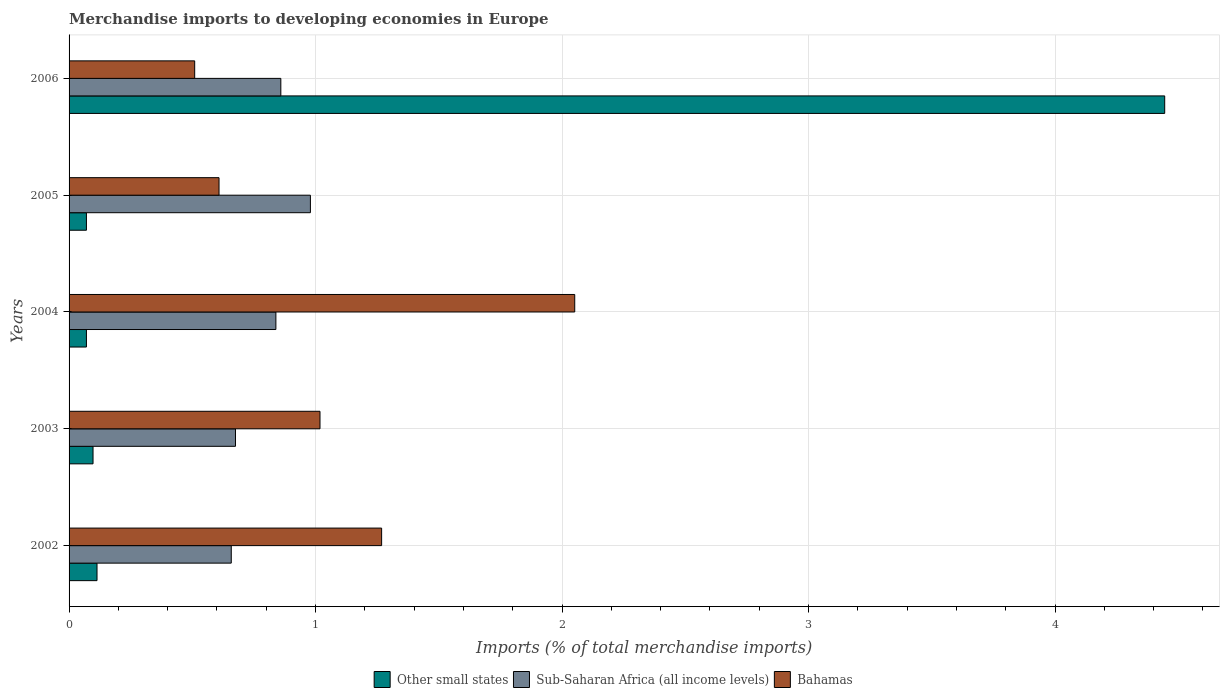How many different coloured bars are there?
Your answer should be compact. 3. Are the number of bars per tick equal to the number of legend labels?
Give a very brief answer. Yes. How many bars are there on the 4th tick from the top?
Provide a succinct answer. 3. How many bars are there on the 4th tick from the bottom?
Your response must be concise. 3. In how many cases, is the number of bars for a given year not equal to the number of legend labels?
Your response must be concise. 0. What is the percentage total merchandise imports in Sub-Saharan Africa (all income levels) in 2002?
Your answer should be very brief. 0.66. Across all years, what is the maximum percentage total merchandise imports in Other small states?
Give a very brief answer. 4.45. Across all years, what is the minimum percentage total merchandise imports in Other small states?
Offer a terse response. 0.07. In which year was the percentage total merchandise imports in Bahamas maximum?
Make the answer very short. 2004. What is the total percentage total merchandise imports in Sub-Saharan Africa (all income levels) in the graph?
Your answer should be very brief. 4.01. What is the difference between the percentage total merchandise imports in Other small states in 2005 and that in 2006?
Your answer should be compact. -4.37. What is the difference between the percentage total merchandise imports in Bahamas in 2004 and the percentage total merchandise imports in Sub-Saharan Africa (all income levels) in 2002?
Provide a short and direct response. 1.39. What is the average percentage total merchandise imports in Bahamas per year?
Offer a terse response. 1.09. In the year 2003, what is the difference between the percentage total merchandise imports in Other small states and percentage total merchandise imports in Sub-Saharan Africa (all income levels)?
Keep it short and to the point. -0.58. In how many years, is the percentage total merchandise imports in Sub-Saharan Africa (all income levels) greater than 4 %?
Provide a short and direct response. 0. What is the ratio of the percentage total merchandise imports in Bahamas in 2002 to that in 2003?
Provide a short and direct response. 1.25. Is the difference between the percentage total merchandise imports in Other small states in 2005 and 2006 greater than the difference between the percentage total merchandise imports in Sub-Saharan Africa (all income levels) in 2005 and 2006?
Offer a terse response. No. What is the difference between the highest and the second highest percentage total merchandise imports in Sub-Saharan Africa (all income levels)?
Provide a succinct answer. 0.12. What is the difference between the highest and the lowest percentage total merchandise imports in Bahamas?
Offer a terse response. 1.54. What does the 3rd bar from the top in 2006 represents?
Keep it short and to the point. Other small states. What does the 3rd bar from the bottom in 2004 represents?
Your response must be concise. Bahamas. How many bars are there?
Offer a terse response. 15. How many years are there in the graph?
Give a very brief answer. 5. What is the difference between two consecutive major ticks on the X-axis?
Ensure brevity in your answer.  1. Are the values on the major ticks of X-axis written in scientific E-notation?
Your answer should be compact. No. Does the graph contain grids?
Offer a very short reply. Yes. Where does the legend appear in the graph?
Ensure brevity in your answer.  Bottom center. How many legend labels are there?
Provide a short and direct response. 3. How are the legend labels stacked?
Provide a short and direct response. Horizontal. What is the title of the graph?
Offer a terse response. Merchandise imports to developing economies in Europe. Does "Tunisia" appear as one of the legend labels in the graph?
Give a very brief answer. No. What is the label or title of the X-axis?
Keep it short and to the point. Imports (% of total merchandise imports). What is the Imports (% of total merchandise imports) in Other small states in 2002?
Offer a terse response. 0.11. What is the Imports (% of total merchandise imports) in Sub-Saharan Africa (all income levels) in 2002?
Your answer should be compact. 0.66. What is the Imports (% of total merchandise imports) of Bahamas in 2002?
Offer a terse response. 1.27. What is the Imports (% of total merchandise imports) of Other small states in 2003?
Ensure brevity in your answer.  0.1. What is the Imports (% of total merchandise imports) of Sub-Saharan Africa (all income levels) in 2003?
Offer a very short reply. 0.68. What is the Imports (% of total merchandise imports) of Bahamas in 2003?
Ensure brevity in your answer.  1.02. What is the Imports (% of total merchandise imports) of Other small states in 2004?
Ensure brevity in your answer.  0.07. What is the Imports (% of total merchandise imports) in Sub-Saharan Africa (all income levels) in 2004?
Offer a very short reply. 0.84. What is the Imports (% of total merchandise imports) in Bahamas in 2004?
Provide a succinct answer. 2.05. What is the Imports (% of total merchandise imports) in Other small states in 2005?
Ensure brevity in your answer.  0.07. What is the Imports (% of total merchandise imports) in Sub-Saharan Africa (all income levels) in 2005?
Ensure brevity in your answer.  0.98. What is the Imports (% of total merchandise imports) of Bahamas in 2005?
Offer a terse response. 0.61. What is the Imports (% of total merchandise imports) of Other small states in 2006?
Make the answer very short. 4.45. What is the Imports (% of total merchandise imports) in Sub-Saharan Africa (all income levels) in 2006?
Offer a very short reply. 0.86. What is the Imports (% of total merchandise imports) of Bahamas in 2006?
Provide a succinct answer. 0.51. Across all years, what is the maximum Imports (% of total merchandise imports) of Other small states?
Your answer should be very brief. 4.45. Across all years, what is the maximum Imports (% of total merchandise imports) of Sub-Saharan Africa (all income levels)?
Give a very brief answer. 0.98. Across all years, what is the maximum Imports (% of total merchandise imports) in Bahamas?
Provide a short and direct response. 2.05. Across all years, what is the minimum Imports (% of total merchandise imports) in Other small states?
Provide a short and direct response. 0.07. Across all years, what is the minimum Imports (% of total merchandise imports) in Sub-Saharan Africa (all income levels)?
Give a very brief answer. 0.66. Across all years, what is the minimum Imports (% of total merchandise imports) in Bahamas?
Offer a terse response. 0.51. What is the total Imports (% of total merchandise imports) of Other small states in the graph?
Provide a succinct answer. 4.8. What is the total Imports (% of total merchandise imports) in Sub-Saharan Africa (all income levels) in the graph?
Provide a succinct answer. 4.01. What is the total Imports (% of total merchandise imports) in Bahamas in the graph?
Provide a succinct answer. 5.46. What is the difference between the Imports (% of total merchandise imports) in Other small states in 2002 and that in 2003?
Offer a terse response. 0.02. What is the difference between the Imports (% of total merchandise imports) in Sub-Saharan Africa (all income levels) in 2002 and that in 2003?
Provide a short and direct response. -0.02. What is the difference between the Imports (% of total merchandise imports) of Bahamas in 2002 and that in 2003?
Provide a succinct answer. 0.25. What is the difference between the Imports (% of total merchandise imports) in Other small states in 2002 and that in 2004?
Your answer should be very brief. 0.04. What is the difference between the Imports (% of total merchandise imports) in Sub-Saharan Africa (all income levels) in 2002 and that in 2004?
Offer a very short reply. -0.18. What is the difference between the Imports (% of total merchandise imports) of Bahamas in 2002 and that in 2004?
Offer a very short reply. -0.78. What is the difference between the Imports (% of total merchandise imports) in Other small states in 2002 and that in 2005?
Provide a short and direct response. 0.04. What is the difference between the Imports (% of total merchandise imports) of Sub-Saharan Africa (all income levels) in 2002 and that in 2005?
Your answer should be very brief. -0.32. What is the difference between the Imports (% of total merchandise imports) in Bahamas in 2002 and that in 2005?
Your response must be concise. 0.66. What is the difference between the Imports (% of total merchandise imports) in Other small states in 2002 and that in 2006?
Your answer should be very brief. -4.33. What is the difference between the Imports (% of total merchandise imports) in Sub-Saharan Africa (all income levels) in 2002 and that in 2006?
Offer a terse response. -0.2. What is the difference between the Imports (% of total merchandise imports) of Bahamas in 2002 and that in 2006?
Your response must be concise. 0.76. What is the difference between the Imports (% of total merchandise imports) of Other small states in 2003 and that in 2004?
Provide a succinct answer. 0.03. What is the difference between the Imports (% of total merchandise imports) in Sub-Saharan Africa (all income levels) in 2003 and that in 2004?
Give a very brief answer. -0.16. What is the difference between the Imports (% of total merchandise imports) in Bahamas in 2003 and that in 2004?
Provide a short and direct response. -1.03. What is the difference between the Imports (% of total merchandise imports) in Other small states in 2003 and that in 2005?
Keep it short and to the point. 0.03. What is the difference between the Imports (% of total merchandise imports) of Sub-Saharan Africa (all income levels) in 2003 and that in 2005?
Ensure brevity in your answer.  -0.3. What is the difference between the Imports (% of total merchandise imports) in Bahamas in 2003 and that in 2005?
Offer a very short reply. 0.41. What is the difference between the Imports (% of total merchandise imports) of Other small states in 2003 and that in 2006?
Your response must be concise. -4.35. What is the difference between the Imports (% of total merchandise imports) of Sub-Saharan Africa (all income levels) in 2003 and that in 2006?
Provide a succinct answer. -0.18. What is the difference between the Imports (% of total merchandise imports) in Bahamas in 2003 and that in 2006?
Provide a short and direct response. 0.51. What is the difference between the Imports (% of total merchandise imports) in Other small states in 2004 and that in 2005?
Give a very brief answer. 0. What is the difference between the Imports (% of total merchandise imports) in Sub-Saharan Africa (all income levels) in 2004 and that in 2005?
Your answer should be very brief. -0.14. What is the difference between the Imports (% of total merchandise imports) in Bahamas in 2004 and that in 2005?
Ensure brevity in your answer.  1.44. What is the difference between the Imports (% of total merchandise imports) in Other small states in 2004 and that in 2006?
Your answer should be compact. -4.37. What is the difference between the Imports (% of total merchandise imports) in Sub-Saharan Africa (all income levels) in 2004 and that in 2006?
Your response must be concise. -0.02. What is the difference between the Imports (% of total merchandise imports) in Bahamas in 2004 and that in 2006?
Your answer should be compact. 1.54. What is the difference between the Imports (% of total merchandise imports) of Other small states in 2005 and that in 2006?
Offer a terse response. -4.37. What is the difference between the Imports (% of total merchandise imports) in Sub-Saharan Africa (all income levels) in 2005 and that in 2006?
Offer a terse response. 0.12. What is the difference between the Imports (% of total merchandise imports) in Bahamas in 2005 and that in 2006?
Provide a short and direct response. 0.1. What is the difference between the Imports (% of total merchandise imports) in Other small states in 2002 and the Imports (% of total merchandise imports) in Sub-Saharan Africa (all income levels) in 2003?
Ensure brevity in your answer.  -0.56. What is the difference between the Imports (% of total merchandise imports) of Other small states in 2002 and the Imports (% of total merchandise imports) of Bahamas in 2003?
Offer a very short reply. -0.9. What is the difference between the Imports (% of total merchandise imports) of Sub-Saharan Africa (all income levels) in 2002 and the Imports (% of total merchandise imports) of Bahamas in 2003?
Your answer should be very brief. -0.36. What is the difference between the Imports (% of total merchandise imports) in Other small states in 2002 and the Imports (% of total merchandise imports) in Sub-Saharan Africa (all income levels) in 2004?
Your answer should be compact. -0.73. What is the difference between the Imports (% of total merchandise imports) of Other small states in 2002 and the Imports (% of total merchandise imports) of Bahamas in 2004?
Offer a very short reply. -1.94. What is the difference between the Imports (% of total merchandise imports) of Sub-Saharan Africa (all income levels) in 2002 and the Imports (% of total merchandise imports) of Bahamas in 2004?
Offer a very short reply. -1.39. What is the difference between the Imports (% of total merchandise imports) in Other small states in 2002 and the Imports (% of total merchandise imports) in Sub-Saharan Africa (all income levels) in 2005?
Offer a terse response. -0.87. What is the difference between the Imports (% of total merchandise imports) of Other small states in 2002 and the Imports (% of total merchandise imports) of Bahamas in 2005?
Provide a short and direct response. -0.49. What is the difference between the Imports (% of total merchandise imports) of Sub-Saharan Africa (all income levels) in 2002 and the Imports (% of total merchandise imports) of Bahamas in 2005?
Your answer should be very brief. 0.05. What is the difference between the Imports (% of total merchandise imports) of Other small states in 2002 and the Imports (% of total merchandise imports) of Sub-Saharan Africa (all income levels) in 2006?
Keep it short and to the point. -0.75. What is the difference between the Imports (% of total merchandise imports) of Other small states in 2002 and the Imports (% of total merchandise imports) of Bahamas in 2006?
Make the answer very short. -0.4. What is the difference between the Imports (% of total merchandise imports) of Sub-Saharan Africa (all income levels) in 2002 and the Imports (% of total merchandise imports) of Bahamas in 2006?
Offer a terse response. 0.15. What is the difference between the Imports (% of total merchandise imports) in Other small states in 2003 and the Imports (% of total merchandise imports) in Sub-Saharan Africa (all income levels) in 2004?
Give a very brief answer. -0.74. What is the difference between the Imports (% of total merchandise imports) of Other small states in 2003 and the Imports (% of total merchandise imports) of Bahamas in 2004?
Provide a succinct answer. -1.95. What is the difference between the Imports (% of total merchandise imports) in Sub-Saharan Africa (all income levels) in 2003 and the Imports (% of total merchandise imports) in Bahamas in 2004?
Your answer should be very brief. -1.38. What is the difference between the Imports (% of total merchandise imports) in Other small states in 2003 and the Imports (% of total merchandise imports) in Sub-Saharan Africa (all income levels) in 2005?
Keep it short and to the point. -0.88. What is the difference between the Imports (% of total merchandise imports) in Other small states in 2003 and the Imports (% of total merchandise imports) in Bahamas in 2005?
Provide a succinct answer. -0.51. What is the difference between the Imports (% of total merchandise imports) in Sub-Saharan Africa (all income levels) in 2003 and the Imports (% of total merchandise imports) in Bahamas in 2005?
Your response must be concise. 0.07. What is the difference between the Imports (% of total merchandise imports) in Other small states in 2003 and the Imports (% of total merchandise imports) in Sub-Saharan Africa (all income levels) in 2006?
Offer a terse response. -0.76. What is the difference between the Imports (% of total merchandise imports) of Other small states in 2003 and the Imports (% of total merchandise imports) of Bahamas in 2006?
Offer a very short reply. -0.41. What is the difference between the Imports (% of total merchandise imports) of Sub-Saharan Africa (all income levels) in 2003 and the Imports (% of total merchandise imports) of Bahamas in 2006?
Offer a terse response. 0.17. What is the difference between the Imports (% of total merchandise imports) in Other small states in 2004 and the Imports (% of total merchandise imports) in Sub-Saharan Africa (all income levels) in 2005?
Your answer should be compact. -0.91. What is the difference between the Imports (% of total merchandise imports) in Other small states in 2004 and the Imports (% of total merchandise imports) in Bahamas in 2005?
Keep it short and to the point. -0.54. What is the difference between the Imports (% of total merchandise imports) in Sub-Saharan Africa (all income levels) in 2004 and the Imports (% of total merchandise imports) in Bahamas in 2005?
Give a very brief answer. 0.23. What is the difference between the Imports (% of total merchandise imports) in Other small states in 2004 and the Imports (% of total merchandise imports) in Sub-Saharan Africa (all income levels) in 2006?
Give a very brief answer. -0.79. What is the difference between the Imports (% of total merchandise imports) in Other small states in 2004 and the Imports (% of total merchandise imports) in Bahamas in 2006?
Offer a terse response. -0.44. What is the difference between the Imports (% of total merchandise imports) of Sub-Saharan Africa (all income levels) in 2004 and the Imports (% of total merchandise imports) of Bahamas in 2006?
Provide a short and direct response. 0.33. What is the difference between the Imports (% of total merchandise imports) of Other small states in 2005 and the Imports (% of total merchandise imports) of Sub-Saharan Africa (all income levels) in 2006?
Ensure brevity in your answer.  -0.79. What is the difference between the Imports (% of total merchandise imports) in Other small states in 2005 and the Imports (% of total merchandise imports) in Bahamas in 2006?
Offer a terse response. -0.44. What is the difference between the Imports (% of total merchandise imports) of Sub-Saharan Africa (all income levels) in 2005 and the Imports (% of total merchandise imports) of Bahamas in 2006?
Give a very brief answer. 0.47. What is the average Imports (% of total merchandise imports) of Other small states per year?
Your response must be concise. 0.96. What is the average Imports (% of total merchandise imports) of Sub-Saharan Africa (all income levels) per year?
Your answer should be compact. 0.8. What is the average Imports (% of total merchandise imports) in Bahamas per year?
Your response must be concise. 1.09. In the year 2002, what is the difference between the Imports (% of total merchandise imports) in Other small states and Imports (% of total merchandise imports) in Sub-Saharan Africa (all income levels)?
Make the answer very short. -0.54. In the year 2002, what is the difference between the Imports (% of total merchandise imports) in Other small states and Imports (% of total merchandise imports) in Bahamas?
Give a very brief answer. -1.15. In the year 2002, what is the difference between the Imports (% of total merchandise imports) of Sub-Saharan Africa (all income levels) and Imports (% of total merchandise imports) of Bahamas?
Your answer should be compact. -0.61. In the year 2003, what is the difference between the Imports (% of total merchandise imports) in Other small states and Imports (% of total merchandise imports) in Sub-Saharan Africa (all income levels)?
Make the answer very short. -0.58. In the year 2003, what is the difference between the Imports (% of total merchandise imports) of Other small states and Imports (% of total merchandise imports) of Bahamas?
Provide a succinct answer. -0.92. In the year 2003, what is the difference between the Imports (% of total merchandise imports) in Sub-Saharan Africa (all income levels) and Imports (% of total merchandise imports) in Bahamas?
Provide a succinct answer. -0.34. In the year 2004, what is the difference between the Imports (% of total merchandise imports) of Other small states and Imports (% of total merchandise imports) of Sub-Saharan Africa (all income levels)?
Provide a short and direct response. -0.77. In the year 2004, what is the difference between the Imports (% of total merchandise imports) of Other small states and Imports (% of total merchandise imports) of Bahamas?
Provide a succinct answer. -1.98. In the year 2004, what is the difference between the Imports (% of total merchandise imports) in Sub-Saharan Africa (all income levels) and Imports (% of total merchandise imports) in Bahamas?
Your response must be concise. -1.21. In the year 2005, what is the difference between the Imports (% of total merchandise imports) of Other small states and Imports (% of total merchandise imports) of Sub-Saharan Africa (all income levels)?
Provide a succinct answer. -0.91. In the year 2005, what is the difference between the Imports (% of total merchandise imports) in Other small states and Imports (% of total merchandise imports) in Bahamas?
Your answer should be compact. -0.54. In the year 2005, what is the difference between the Imports (% of total merchandise imports) in Sub-Saharan Africa (all income levels) and Imports (% of total merchandise imports) in Bahamas?
Provide a short and direct response. 0.37. In the year 2006, what is the difference between the Imports (% of total merchandise imports) of Other small states and Imports (% of total merchandise imports) of Sub-Saharan Africa (all income levels)?
Keep it short and to the point. 3.59. In the year 2006, what is the difference between the Imports (% of total merchandise imports) of Other small states and Imports (% of total merchandise imports) of Bahamas?
Ensure brevity in your answer.  3.94. In the year 2006, what is the difference between the Imports (% of total merchandise imports) in Sub-Saharan Africa (all income levels) and Imports (% of total merchandise imports) in Bahamas?
Your answer should be compact. 0.35. What is the ratio of the Imports (% of total merchandise imports) in Other small states in 2002 to that in 2003?
Ensure brevity in your answer.  1.17. What is the ratio of the Imports (% of total merchandise imports) in Sub-Saharan Africa (all income levels) in 2002 to that in 2003?
Provide a short and direct response. 0.97. What is the ratio of the Imports (% of total merchandise imports) of Bahamas in 2002 to that in 2003?
Provide a short and direct response. 1.25. What is the ratio of the Imports (% of total merchandise imports) in Other small states in 2002 to that in 2004?
Your answer should be compact. 1.61. What is the ratio of the Imports (% of total merchandise imports) of Sub-Saharan Africa (all income levels) in 2002 to that in 2004?
Your answer should be very brief. 0.78. What is the ratio of the Imports (% of total merchandise imports) in Bahamas in 2002 to that in 2004?
Keep it short and to the point. 0.62. What is the ratio of the Imports (% of total merchandise imports) in Other small states in 2002 to that in 2005?
Give a very brief answer. 1.61. What is the ratio of the Imports (% of total merchandise imports) in Sub-Saharan Africa (all income levels) in 2002 to that in 2005?
Your answer should be very brief. 0.67. What is the ratio of the Imports (% of total merchandise imports) of Bahamas in 2002 to that in 2005?
Offer a terse response. 2.08. What is the ratio of the Imports (% of total merchandise imports) in Other small states in 2002 to that in 2006?
Give a very brief answer. 0.03. What is the ratio of the Imports (% of total merchandise imports) of Sub-Saharan Africa (all income levels) in 2002 to that in 2006?
Give a very brief answer. 0.77. What is the ratio of the Imports (% of total merchandise imports) of Bahamas in 2002 to that in 2006?
Offer a very short reply. 2.49. What is the ratio of the Imports (% of total merchandise imports) of Other small states in 2003 to that in 2004?
Provide a succinct answer. 1.38. What is the ratio of the Imports (% of total merchandise imports) in Sub-Saharan Africa (all income levels) in 2003 to that in 2004?
Ensure brevity in your answer.  0.8. What is the ratio of the Imports (% of total merchandise imports) in Bahamas in 2003 to that in 2004?
Provide a succinct answer. 0.5. What is the ratio of the Imports (% of total merchandise imports) of Other small states in 2003 to that in 2005?
Your response must be concise. 1.38. What is the ratio of the Imports (% of total merchandise imports) of Sub-Saharan Africa (all income levels) in 2003 to that in 2005?
Provide a short and direct response. 0.69. What is the ratio of the Imports (% of total merchandise imports) of Bahamas in 2003 to that in 2005?
Make the answer very short. 1.67. What is the ratio of the Imports (% of total merchandise imports) in Other small states in 2003 to that in 2006?
Your response must be concise. 0.02. What is the ratio of the Imports (% of total merchandise imports) in Sub-Saharan Africa (all income levels) in 2003 to that in 2006?
Your answer should be very brief. 0.79. What is the ratio of the Imports (% of total merchandise imports) in Bahamas in 2003 to that in 2006?
Offer a terse response. 2. What is the ratio of the Imports (% of total merchandise imports) in Other small states in 2004 to that in 2005?
Give a very brief answer. 1. What is the ratio of the Imports (% of total merchandise imports) in Sub-Saharan Africa (all income levels) in 2004 to that in 2005?
Offer a very short reply. 0.86. What is the ratio of the Imports (% of total merchandise imports) of Bahamas in 2004 to that in 2005?
Your answer should be very brief. 3.37. What is the ratio of the Imports (% of total merchandise imports) of Other small states in 2004 to that in 2006?
Provide a short and direct response. 0.02. What is the ratio of the Imports (% of total merchandise imports) in Sub-Saharan Africa (all income levels) in 2004 to that in 2006?
Your response must be concise. 0.98. What is the ratio of the Imports (% of total merchandise imports) in Bahamas in 2004 to that in 2006?
Make the answer very short. 4.03. What is the ratio of the Imports (% of total merchandise imports) in Other small states in 2005 to that in 2006?
Ensure brevity in your answer.  0.02. What is the ratio of the Imports (% of total merchandise imports) of Sub-Saharan Africa (all income levels) in 2005 to that in 2006?
Offer a terse response. 1.14. What is the ratio of the Imports (% of total merchandise imports) in Bahamas in 2005 to that in 2006?
Make the answer very short. 1.19. What is the difference between the highest and the second highest Imports (% of total merchandise imports) of Other small states?
Provide a succinct answer. 4.33. What is the difference between the highest and the second highest Imports (% of total merchandise imports) of Sub-Saharan Africa (all income levels)?
Offer a terse response. 0.12. What is the difference between the highest and the second highest Imports (% of total merchandise imports) in Bahamas?
Offer a terse response. 0.78. What is the difference between the highest and the lowest Imports (% of total merchandise imports) in Other small states?
Ensure brevity in your answer.  4.37. What is the difference between the highest and the lowest Imports (% of total merchandise imports) of Sub-Saharan Africa (all income levels)?
Provide a short and direct response. 0.32. What is the difference between the highest and the lowest Imports (% of total merchandise imports) of Bahamas?
Give a very brief answer. 1.54. 